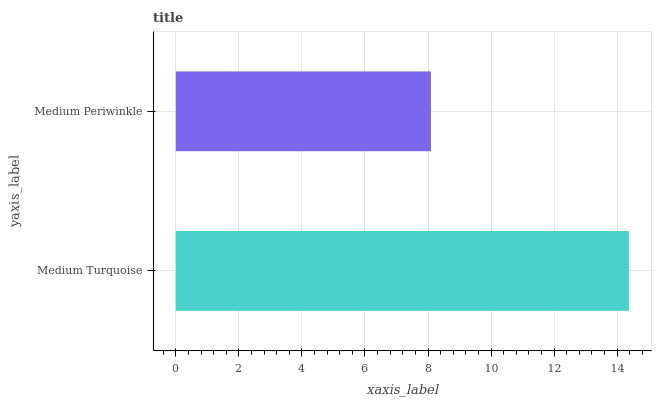Is Medium Periwinkle the minimum?
Answer yes or no. Yes. Is Medium Turquoise the maximum?
Answer yes or no. Yes. Is Medium Periwinkle the maximum?
Answer yes or no. No. Is Medium Turquoise greater than Medium Periwinkle?
Answer yes or no. Yes. Is Medium Periwinkle less than Medium Turquoise?
Answer yes or no. Yes. Is Medium Periwinkle greater than Medium Turquoise?
Answer yes or no. No. Is Medium Turquoise less than Medium Periwinkle?
Answer yes or no. No. Is Medium Turquoise the high median?
Answer yes or no. Yes. Is Medium Periwinkle the low median?
Answer yes or no. Yes. Is Medium Periwinkle the high median?
Answer yes or no. No. Is Medium Turquoise the low median?
Answer yes or no. No. 